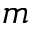Convert formula to latex. <formula><loc_0><loc_0><loc_500><loc_500>m</formula> 